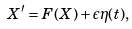<formula> <loc_0><loc_0><loc_500><loc_500>X ^ { \prime } = F ( X ) + \epsilon \eta ( t ) ,</formula> 